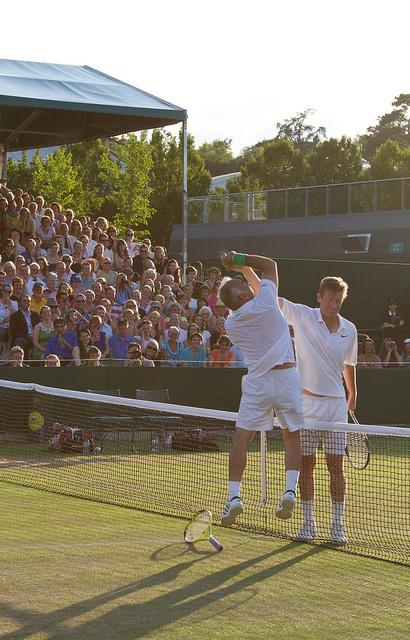What is the profession of the men in white? Please explain your reasoning. athletes. The profession is an athlete. 